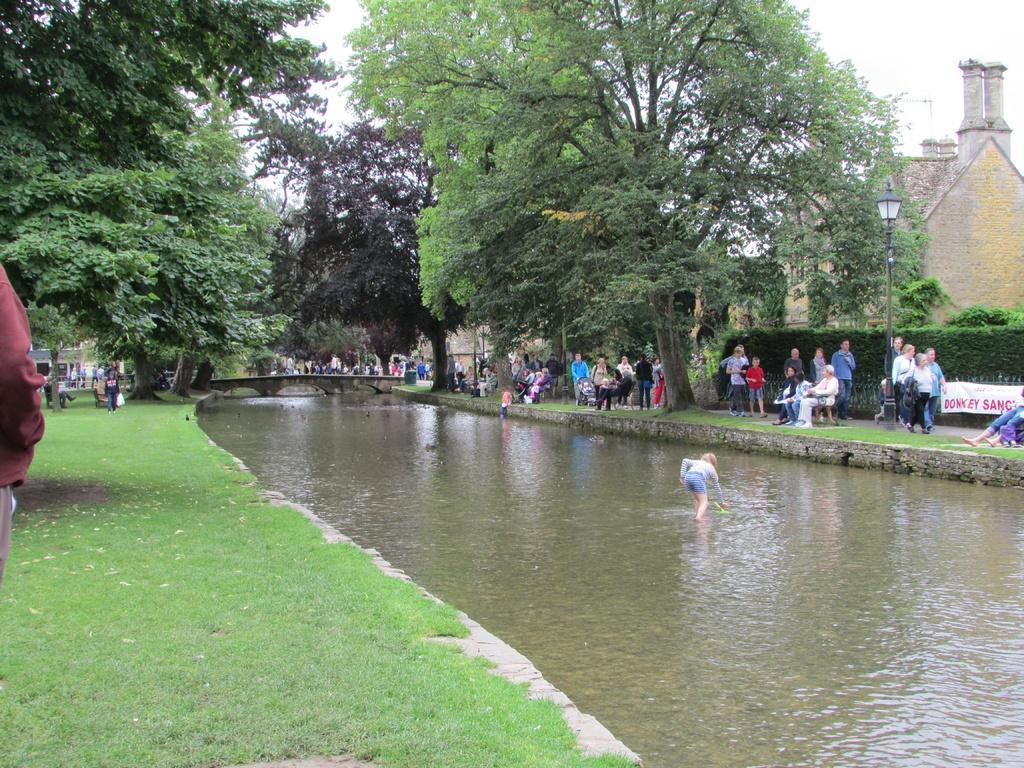Please provide a concise description of this image. There is a river and around the river there is a park and many people were moving around the park and there is a kid walking into the river, there is a bridge across the river and there is a kid walking into the river. There is a bridge across the river and around the bridge there are many trees. 